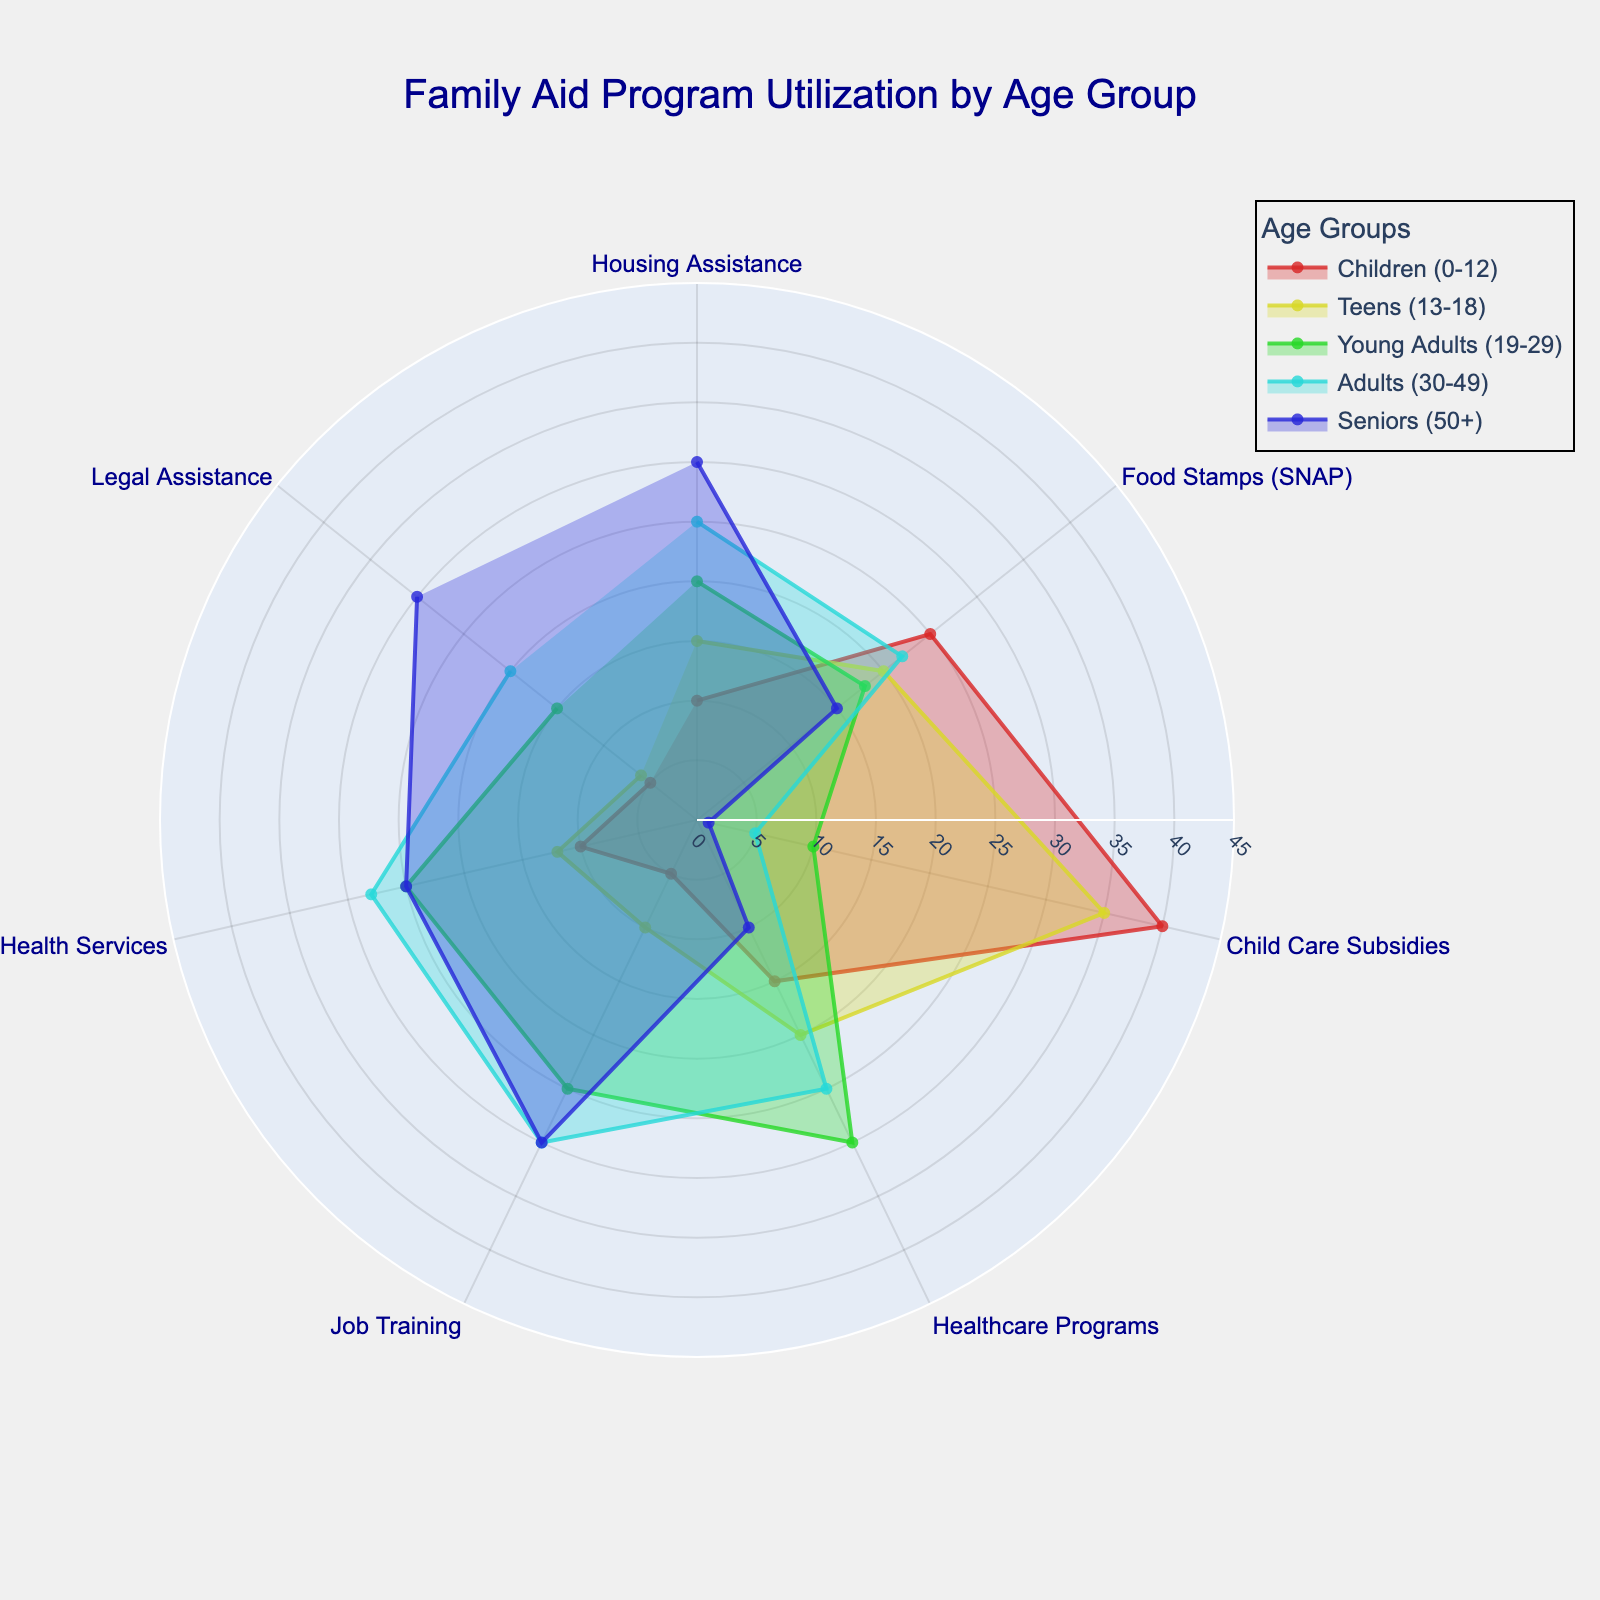what's the title of the chart? Look at the top center of the figure; it will have the title.
Answer: Family Aid Program Utilization by Age Group How many family aid programs are shown in the chart? Count the number of distinct categories (labels) on the angular axis.
Answer: 7 Which age group utilizes Child Care Subsidies the most? Look at the 'Child Care Subsidies' label and find the group with the largest radius extending from the origin.
Answer: Children (0-12) For the Food Stamps (SNAP) program, which age group has the lowest utilization rate? Check the 'Food Stamps (SNAP)' label and find the age group with the smallest radius extending from the origin.
Answer: Seniors (50+) What is the difference in the utilization rate of Housing Assistance between Young Adults (19-29) and Seniors (50+)? Identify the radii corresponding to Young Adults (20) and Seniors (30) for Housing Assistance, then subtract the smaller from the larger.
Answer: 10 What's the average utilization rate of Mental Health Services among all age groups? Add up the utilization rates for Mental Health Services for all age groups (10+12+25+28+25=100) and divide by the number of age groups (5).
Answer: 20 Which program shows the least variation in utilization across different age groups? Look for the program where the lengths of the radii (bars) are closest in size.
Answer: Legal Assistance Does any age group have the highest utilization rate for more than one program? If yes, which age group and programs? Check each program and identify age groups with the highest radius, then see if any age group appears more than once.
Answer: Children (0-12) - Child Care Subsidies and Food Stamps (SNAP) In which program do Adults (30-49) have their highest utilization rate, and what is that rate? Find the longest bar for the Adults (30-49) group and note the corresponding program's label and its length.
Answer: Job Training, 30 